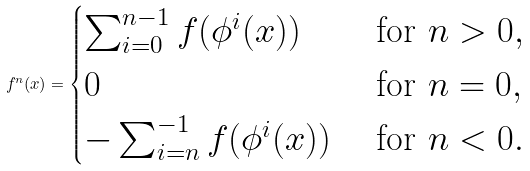<formula> <loc_0><loc_0><loc_500><loc_500>f ^ { n } ( x ) = \begin{cases} \sum _ { i = 0 } ^ { n - 1 } f ( \phi ^ { i } ( x ) ) & \text { for } n > 0 , \\ 0 & \text { for } n = 0 , \\ - \sum _ { i = n } ^ { - 1 } f ( \phi ^ { i } ( x ) ) & \text { for } n < 0 . \end{cases}</formula> 